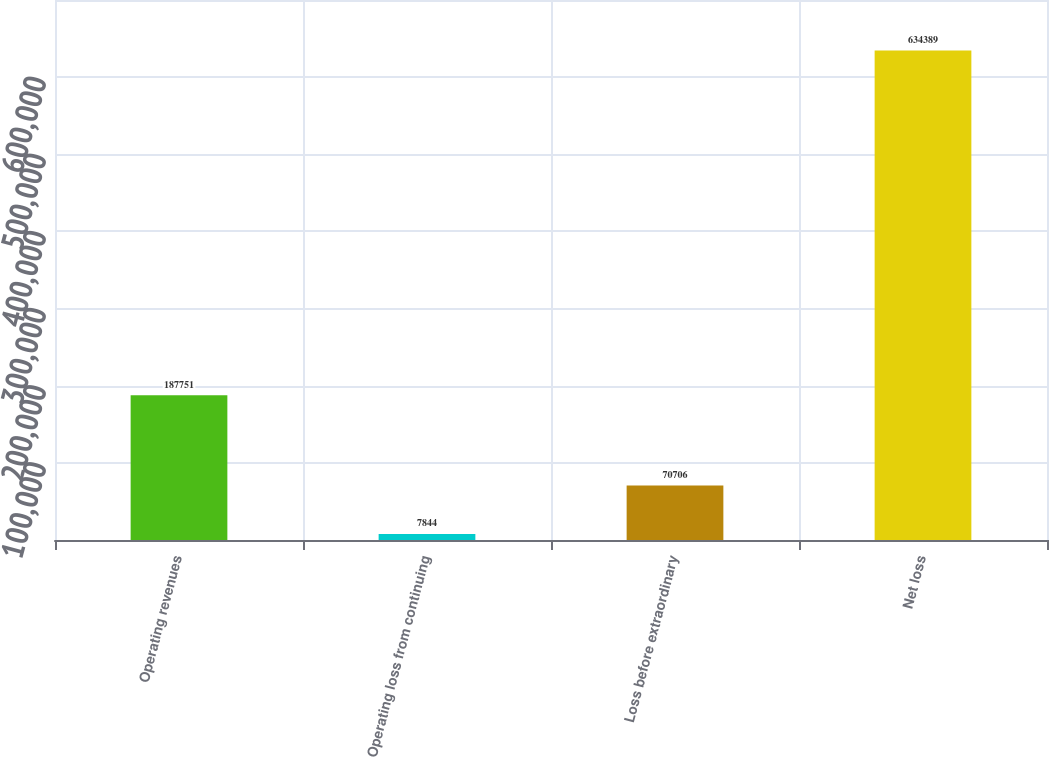<chart> <loc_0><loc_0><loc_500><loc_500><bar_chart><fcel>Operating revenues<fcel>Operating loss from continuing<fcel>Loss before extraordinary<fcel>Net loss<nl><fcel>187751<fcel>7844<fcel>70706<fcel>634389<nl></chart> 